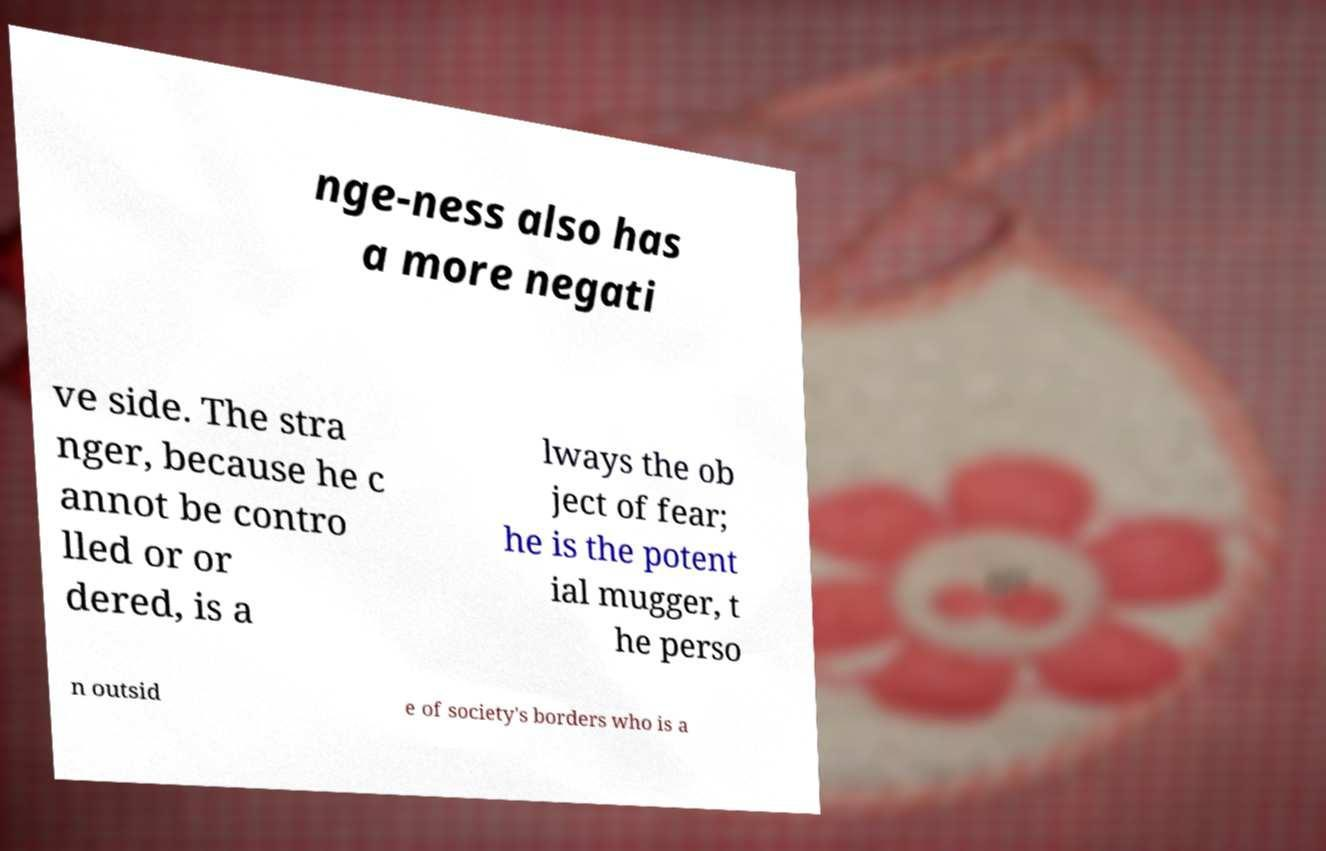Could you extract and type out the text from this image? nge-ness also has a more negati ve side. The stra nger, because he c annot be contro lled or or dered, is a lways the ob ject of fear; he is the potent ial mugger, t he perso n outsid e of society's borders who is a 